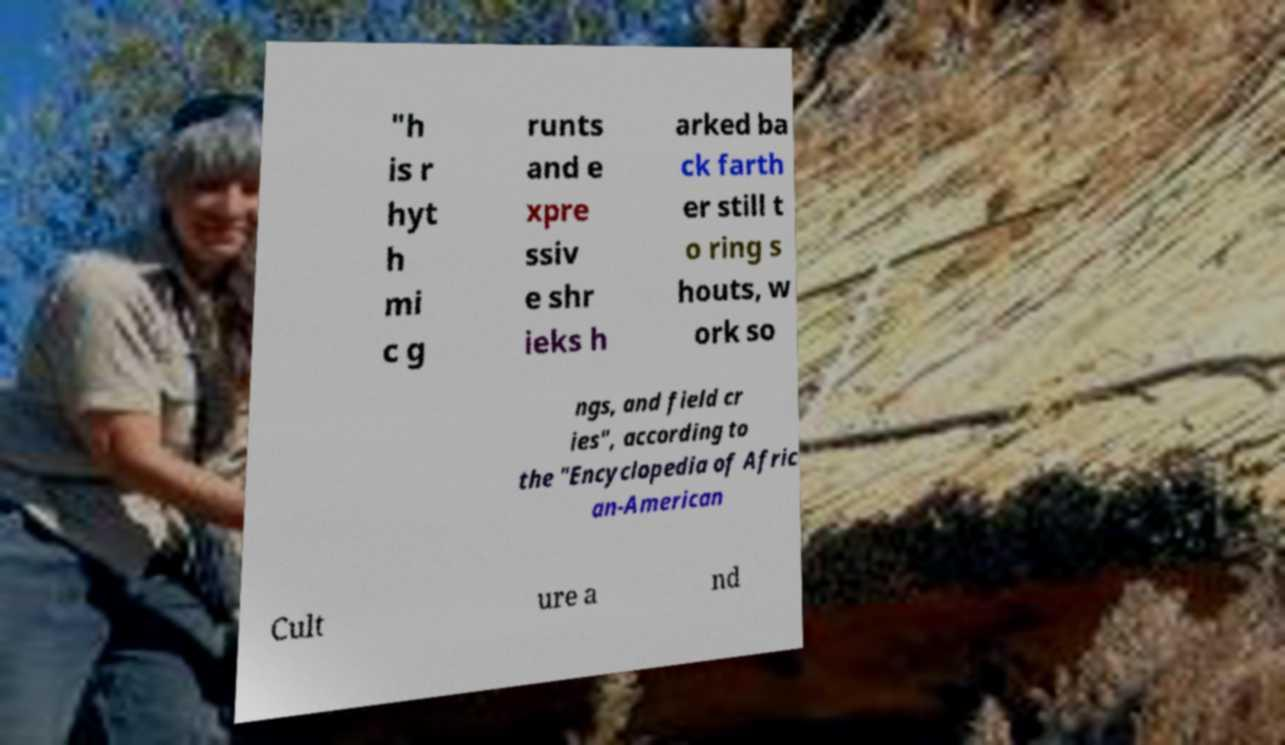Please read and relay the text visible in this image. What does it say? "h is r hyt h mi c g runts and e xpre ssiv e shr ieks h arked ba ck farth er still t o ring s houts, w ork so ngs, and field cr ies", according to the "Encyclopedia of Afric an-American Cult ure a nd 